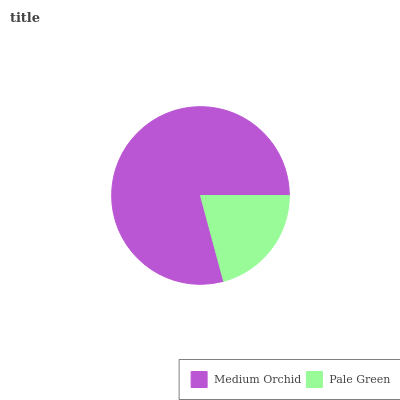Is Pale Green the minimum?
Answer yes or no. Yes. Is Medium Orchid the maximum?
Answer yes or no. Yes. Is Pale Green the maximum?
Answer yes or no. No. Is Medium Orchid greater than Pale Green?
Answer yes or no. Yes. Is Pale Green less than Medium Orchid?
Answer yes or no. Yes. Is Pale Green greater than Medium Orchid?
Answer yes or no. No. Is Medium Orchid less than Pale Green?
Answer yes or no. No. Is Medium Orchid the high median?
Answer yes or no. Yes. Is Pale Green the low median?
Answer yes or no. Yes. Is Pale Green the high median?
Answer yes or no. No. Is Medium Orchid the low median?
Answer yes or no. No. 